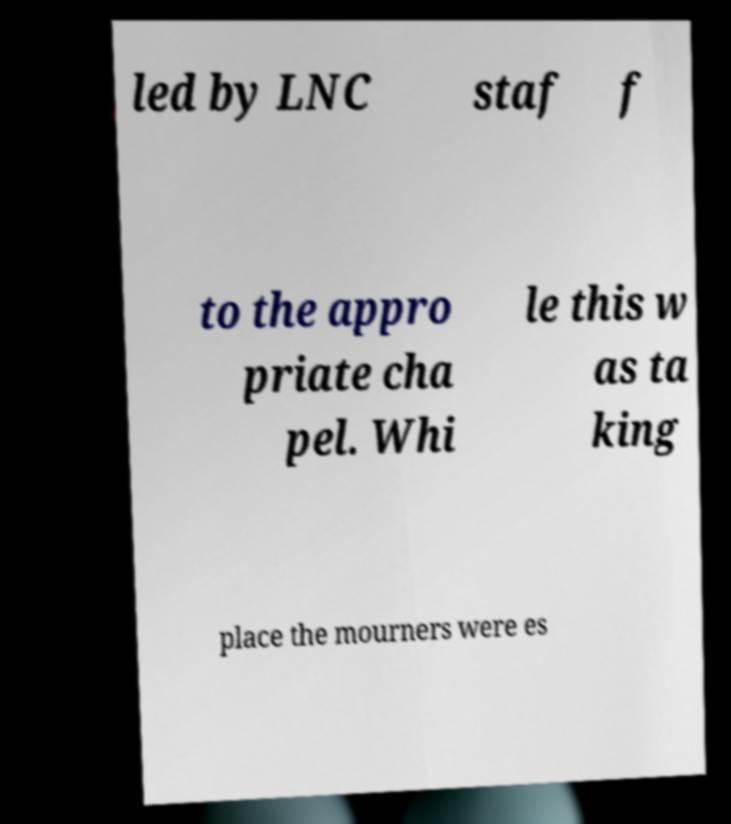For documentation purposes, I need the text within this image transcribed. Could you provide that? led by LNC staf f to the appro priate cha pel. Whi le this w as ta king place the mourners were es 